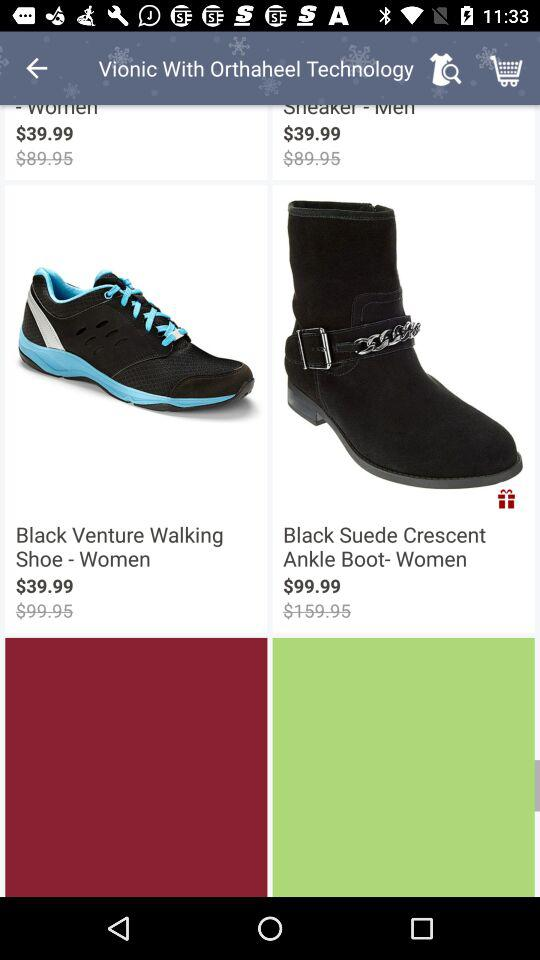What currency is used for the price? The currency used for the price is dollars. 